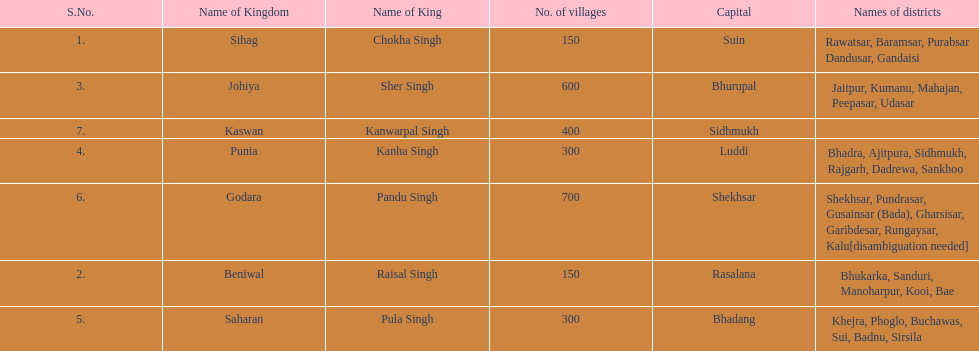What was the total number of districts within the state of godara? 7. 